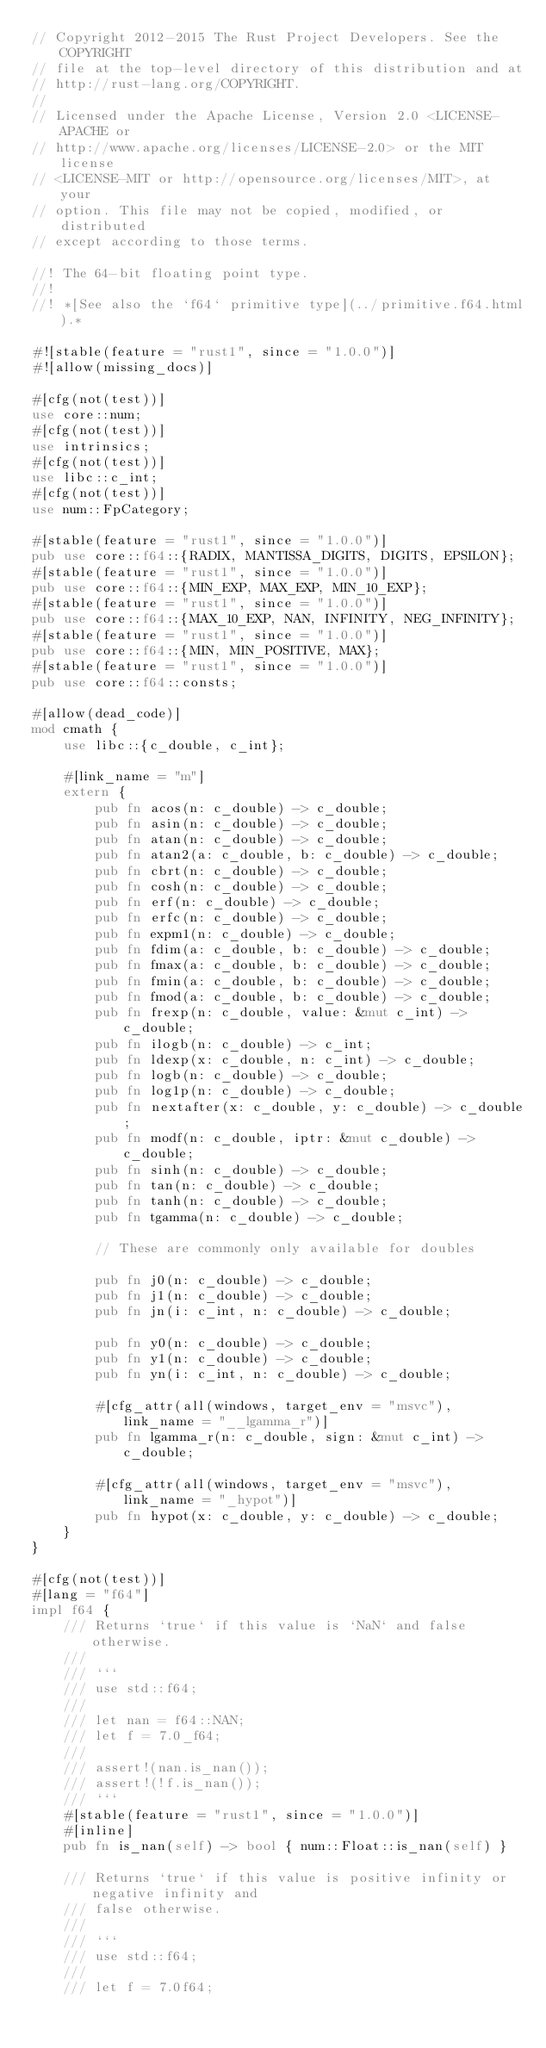Convert code to text. <code><loc_0><loc_0><loc_500><loc_500><_Rust_>// Copyright 2012-2015 The Rust Project Developers. See the COPYRIGHT
// file at the top-level directory of this distribution and at
// http://rust-lang.org/COPYRIGHT.
//
// Licensed under the Apache License, Version 2.0 <LICENSE-APACHE or
// http://www.apache.org/licenses/LICENSE-2.0> or the MIT license
// <LICENSE-MIT or http://opensource.org/licenses/MIT>, at your
// option. This file may not be copied, modified, or distributed
// except according to those terms.

//! The 64-bit floating point type.
//!
//! *[See also the `f64` primitive type](../primitive.f64.html).*

#![stable(feature = "rust1", since = "1.0.0")]
#![allow(missing_docs)]

#[cfg(not(test))]
use core::num;
#[cfg(not(test))]
use intrinsics;
#[cfg(not(test))]
use libc::c_int;
#[cfg(not(test))]
use num::FpCategory;

#[stable(feature = "rust1", since = "1.0.0")]
pub use core::f64::{RADIX, MANTISSA_DIGITS, DIGITS, EPSILON};
#[stable(feature = "rust1", since = "1.0.0")]
pub use core::f64::{MIN_EXP, MAX_EXP, MIN_10_EXP};
#[stable(feature = "rust1", since = "1.0.0")]
pub use core::f64::{MAX_10_EXP, NAN, INFINITY, NEG_INFINITY};
#[stable(feature = "rust1", since = "1.0.0")]
pub use core::f64::{MIN, MIN_POSITIVE, MAX};
#[stable(feature = "rust1", since = "1.0.0")]
pub use core::f64::consts;

#[allow(dead_code)]
mod cmath {
    use libc::{c_double, c_int};

    #[link_name = "m"]
    extern {
        pub fn acos(n: c_double) -> c_double;
        pub fn asin(n: c_double) -> c_double;
        pub fn atan(n: c_double) -> c_double;
        pub fn atan2(a: c_double, b: c_double) -> c_double;
        pub fn cbrt(n: c_double) -> c_double;
        pub fn cosh(n: c_double) -> c_double;
        pub fn erf(n: c_double) -> c_double;
        pub fn erfc(n: c_double) -> c_double;
        pub fn expm1(n: c_double) -> c_double;
        pub fn fdim(a: c_double, b: c_double) -> c_double;
        pub fn fmax(a: c_double, b: c_double) -> c_double;
        pub fn fmin(a: c_double, b: c_double) -> c_double;
        pub fn fmod(a: c_double, b: c_double) -> c_double;
        pub fn frexp(n: c_double, value: &mut c_int) -> c_double;
        pub fn ilogb(n: c_double) -> c_int;
        pub fn ldexp(x: c_double, n: c_int) -> c_double;
        pub fn logb(n: c_double) -> c_double;
        pub fn log1p(n: c_double) -> c_double;
        pub fn nextafter(x: c_double, y: c_double) -> c_double;
        pub fn modf(n: c_double, iptr: &mut c_double) -> c_double;
        pub fn sinh(n: c_double) -> c_double;
        pub fn tan(n: c_double) -> c_double;
        pub fn tanh(n: c_double) -> c_double;
        pub fn tgamma(n: c_double) -> c_double;

        // These are commonly only available for doubles

        pub fn j0(n: c_double) -> c_double;
        pub fn j1(n: c_double) -> c_double;
        pub fn jn(i: c_int, n: c_double) -> c_double;

        pub fn y0(n: c_double) -> c_double;
        pub fn y1(n: c_double) -> c_double;
        pub fn yn(i: c_int, n: c_double) -> c_double;

        #[cfg_attr(all(windows, target_env = "msvc"), link_name = "__lgamma_r")]
        pub fn lgamma_r(n: c_double, sign: &mut c_int) -> c_double;

        #[cfg_attr(all(windows, target_env = "msvc"), link_name = "_hypot")]
        pub fn hypot(x: c_double, y: c_double) -> c_double;
    }
}

#[cfg(not(test))]
#[lang = "f64"]
impl f64 {
    /// Returns `true` if this value is `NaN` and false otherwise.
    ///
    /// ```
    /// use std::f64;
    ///
    /// let nan = f64::NAN;
    /// let f = 7.0_f64;
    ///
    /// assert!(nan.is_nan());
    /// assert!(!f.is_nan());
    /// ```
    #[stable(feature = "rust1", since = "1.0.0")]
    #[inline]
    pub fn is_nan(self) -> bool { num::Float::is_nan(self) }

    /// Returns `true` if this value is positive infinity or negative infinity and
    /// false otherwise.
    ///
    /// ```
    /// use std::f64;
    ///
    /// let f = 7.0f64;</code> 